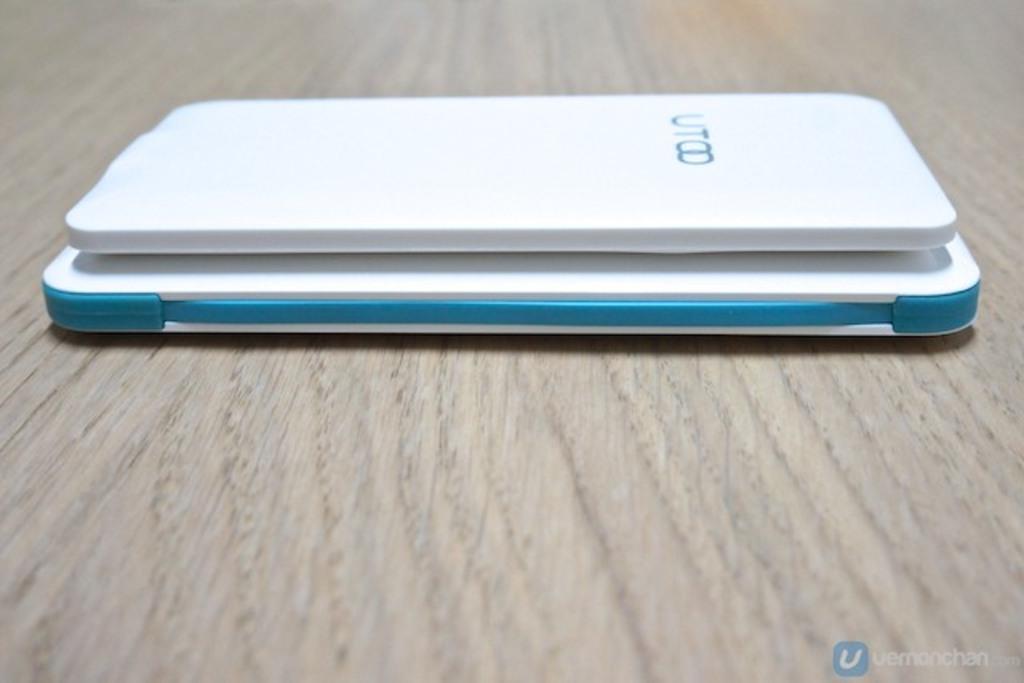What type of phone is this?
Your answer should be very brief. Utoo. 